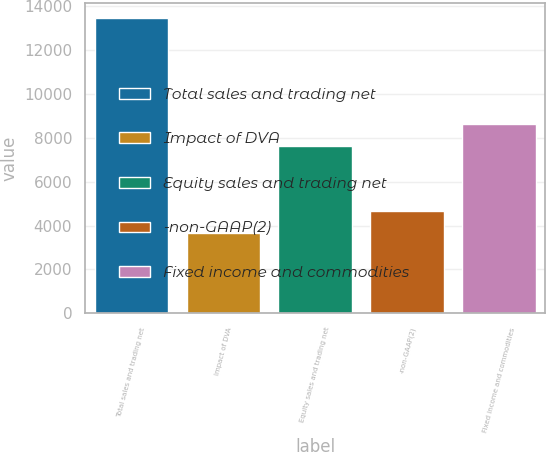Convert chart to OTSL. <chart><loc_0><loc_0><loc_500><loc_500><bar_chart><fcel>Total sales and trading net<fcel>Impact of DVA<fcel>Equity sales and trading net<fcel>-non-GAAP(2)<fcel>Fixed income and commodities<nl><fcel>13440<fcel>3681<fcel>7619.9<fcel>4656.9<fcel>8595.8<nl></chart> 